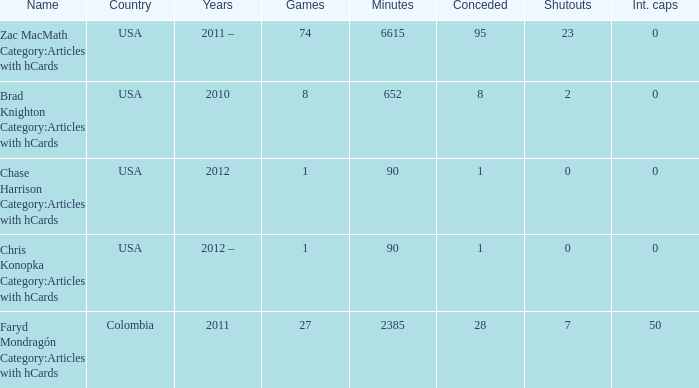When 2010 is the year what is the game? 8.0. 